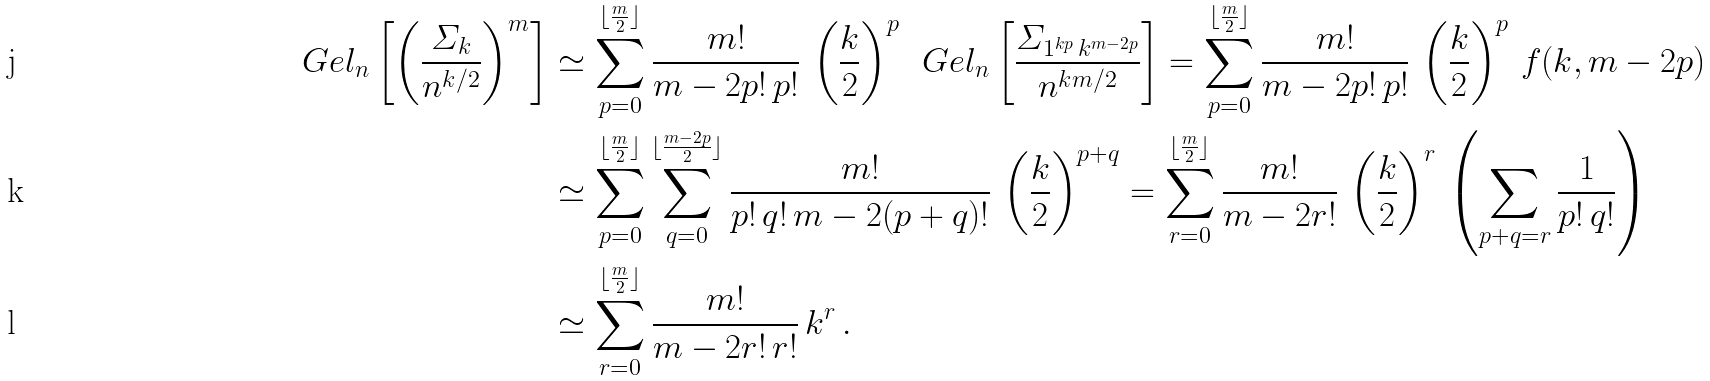<formula> <loc_0><loc_0><loc_500><loc_500>\ G e l _ { n } \left [ \left ( \frac { \varSigma _ { k } } { n ^ { k / 2 } } \right ) ^ { m } \right ] & \simeq \sum _ { p = 0 } ^ { \lfloor \frac { m } { 2 } \rfloor } \frac { m ! } { m - 2 p ! \, p ! } \, \left ( \frac { k } { 2 } \right ) ^ { p } \, \ G e l _ { n } \left [ \frac { \varSigma _ { 1 ^ { k p } \, k ^ { m - 2 p } } } { n ^ { k m / 2 } } \right ] = \sum _ { p = 0 } ^ { \lfloor \frac { m } { 2 } \rfloor } \frac { m ! } { m - 2 p ! \, p ! } \, \left ( \frac { k } { 2 } \right ) ^ { p } \, f ( k , m - 2 p ) \\ & \simeq \sum _ { p = 0 } ^ { \lfloor \frac { m } { 2 } \rfloor } \sum _ { q = 0 } ^ { \lfloor \frac { m - 2 p } { 2 } \rfloor } \frac { m ! } { p ! \, q ! \, m - 2 ( p + q ) ! } \, \left ( \frac { k } { 2 } \right ) ^ { p + q } = \sum _ { r = 0 } ^ { \lfloor \frac { m } { 2 } \rfloor } \frac { m ! } { m - 2 r ! } \, \left ( \frac { k } { 2 } \right ) ^ { r } \, \left ( \sum _ { p + q = r } \frac { 1 } { p ! \, q ! } \right ) \\ & \simeq \sum _ { r = 0 } ^ { \lfloor \frac { m } { 2 } \rfloor } \frac { m ! } { m - 2 r ! \, r ! } \, k ^ { r } \, .</formula> 